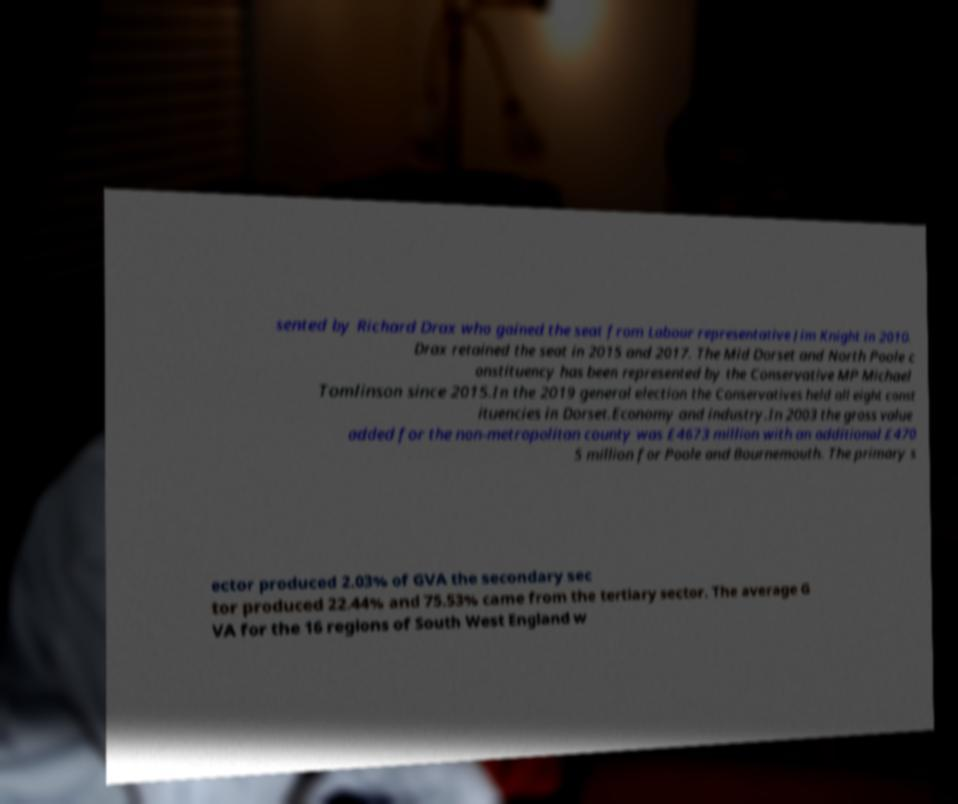Could you extract and type out the text from this image? sented by Richard Drax who gained the seat from Labour representative Jim Knight in 2010. Drax retained the seat in 2015 and 2017. The Mid Dorset and North Poole c onstituency has been represented by the Conservative MP Michael Tomlinson since 2015.In the 2019 general election the Conservatives held all eight const ituencies in Dorset.Economy and industry.In 2003 the gross value added for the non-metropolitan county was £4673 million with an additional £470 5 million for Poole and Bournemouth. The primary s ector produced 2.03% of GVA the secondary sec tor produced 22.44% and 75.53% came from the tertiary sector. The average G VA for the 16 regions of South West England w 